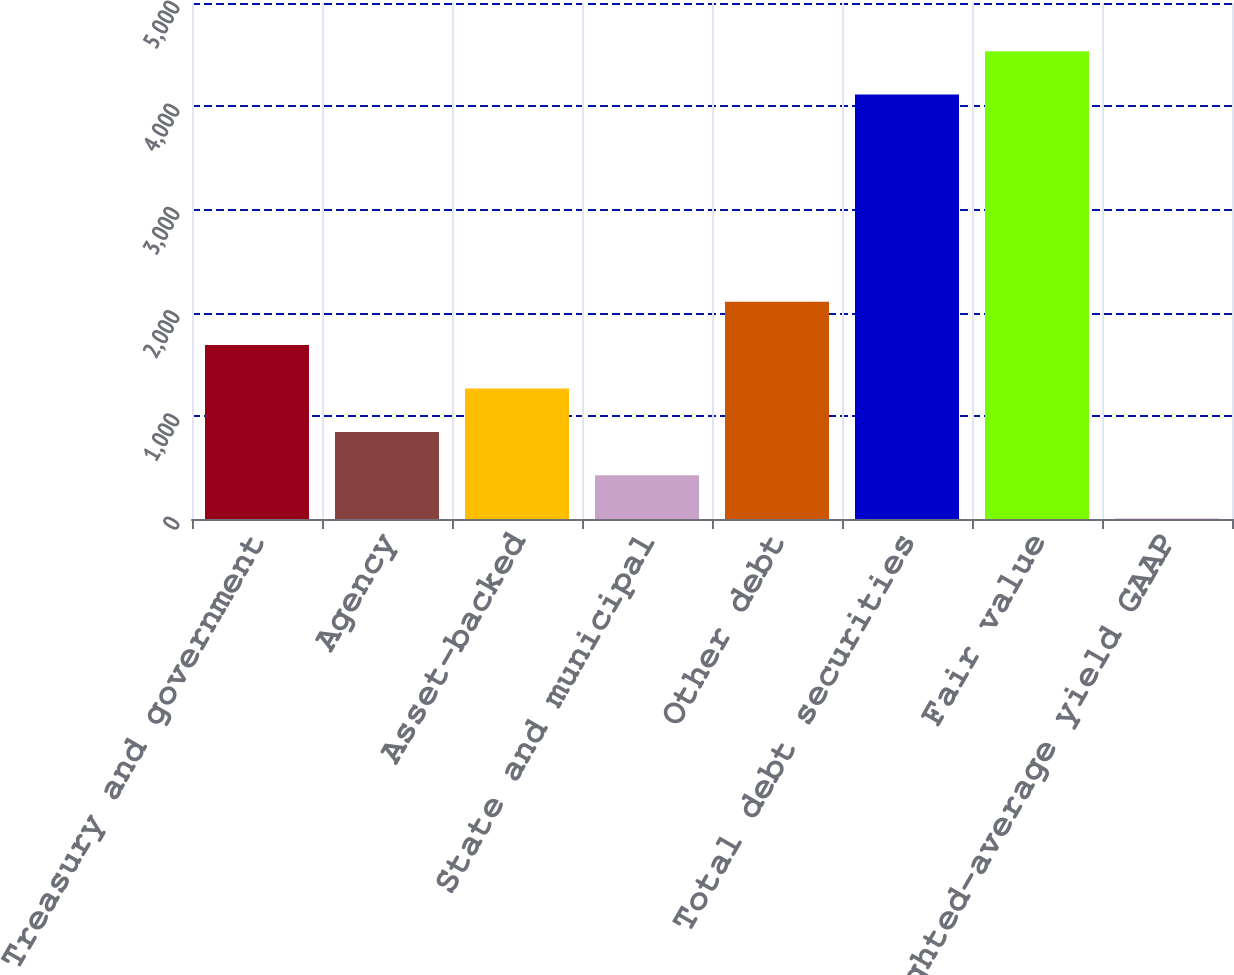<chart> <loc_0><loc_0><loc_500><loc_500><bar_chart><fcel>US Treasury and government<fcel>Agency<fcel>Asset-backed<fcel>State and municipal<fcel>Other debt<fcel>Total debt securities<fcel>Fair value<fcel>Weighted-average yield GAAP<nl><fcel>1685.09<fcel>843.79<fcel>1264.44<fcel>423.14<fcel>2105.74<fcel>4113<fcel>4533.65<fcel>2.49<nl></chart> 